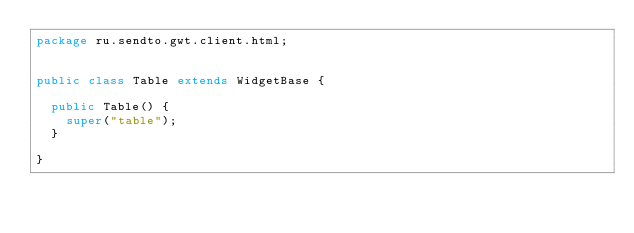<code> <loc_0><loc_0><loc_500><loc_500><_Java_>package ru.sendto.gwt.client.html;


public class Table extends WidgetBase {
	
	public Table() {
		super("table");
	}

}
</code> 